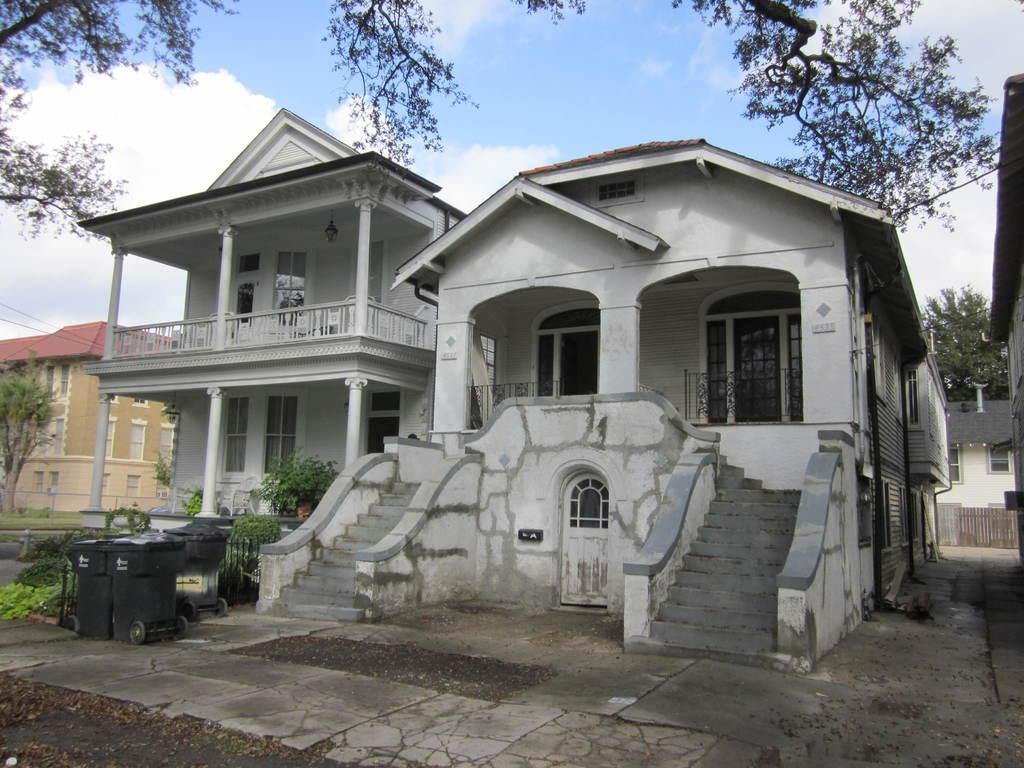Can you describe this image briefly? In this image we can see some buildings with windows, doors and railings. On the left side of the image we can see trash bins placed on the ground, some plants and grass. At the top of the image we can see some trees and the sky. 